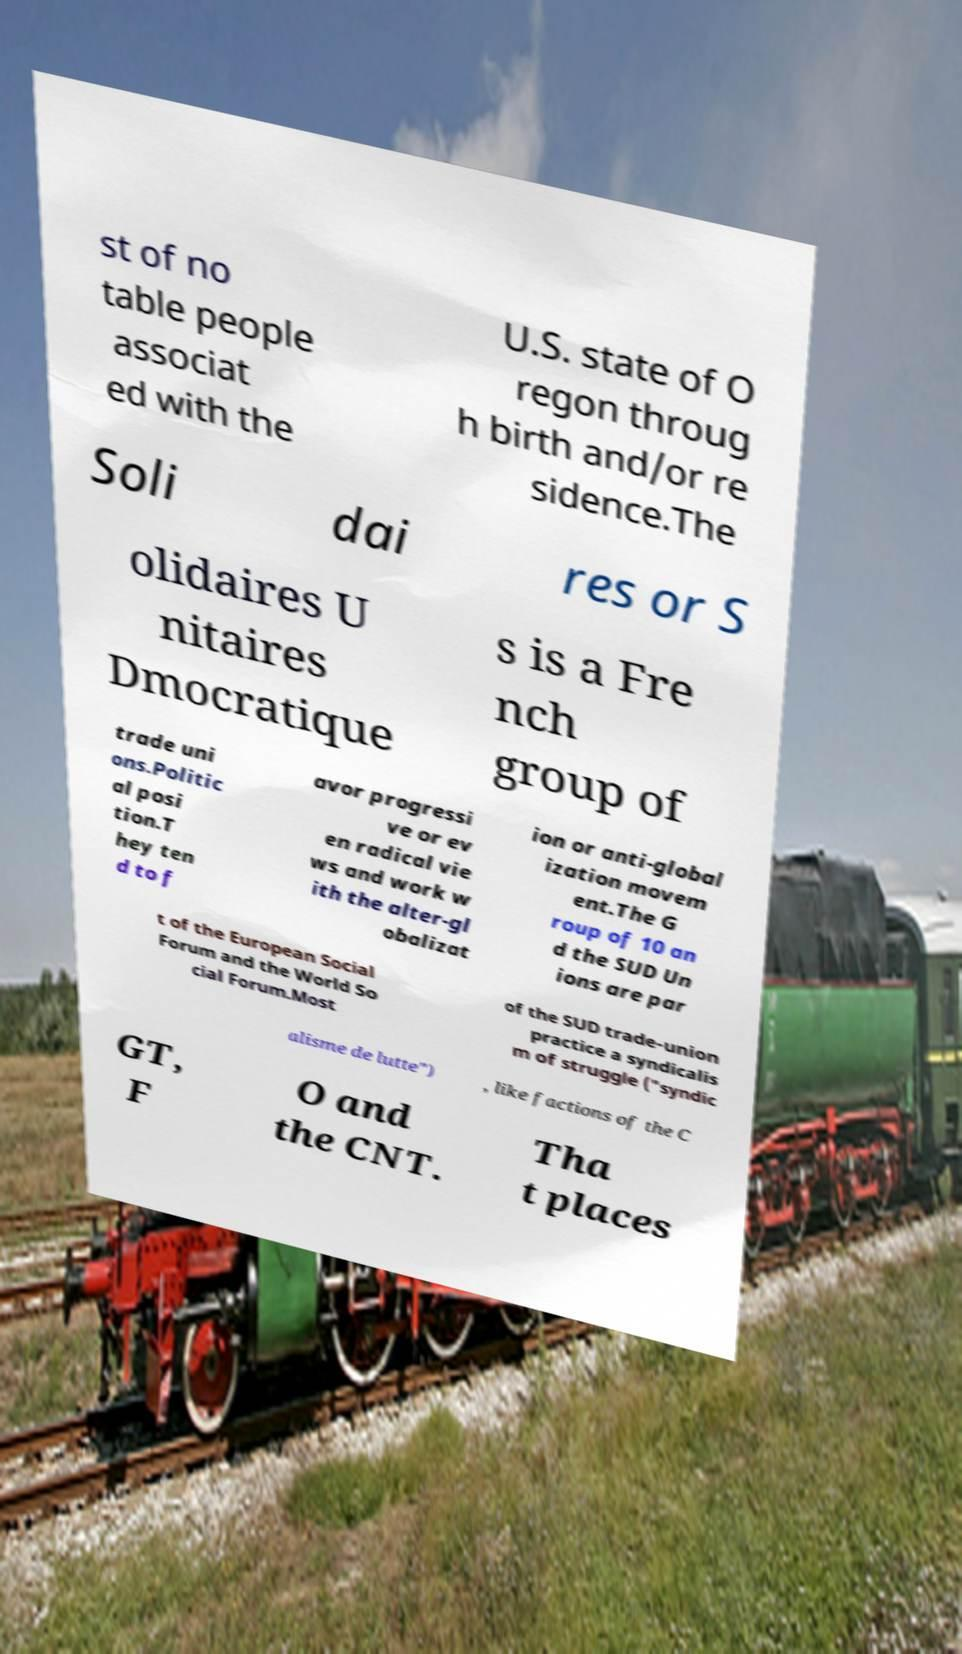There's text embedded in this image that I need extracted. Can you transcribe it verbatim? st of no table people associat ed with the U.S. state of O regon throug h birth and/or re sidence.The Soli dai res or S olidaires U nitaires Dmocratique s is a Fre nch group of trade uni ons.Politic al posi tion.T hey ten d to f avor progressi ve or ev en radical vie ws and work w ith the alter-gl obalizat ion or anti-global ization movem ent.The G roup of 10 an d the SUD Un ions are par t of the European Social Forum and the World So cial Forum.Most of the SUD trade-union practice a syndicalis m of struggle ("syndic alisme de lutte") , like factions of the C GT, F O and the CNT. Tha t places 